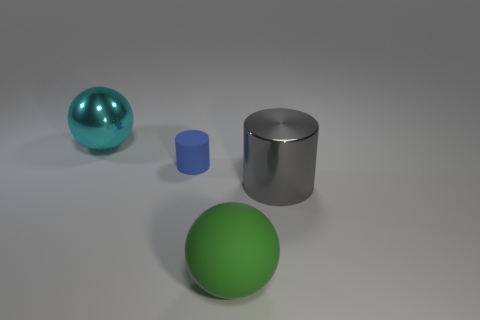Add 4 yellow matte cylinders. How many objects exist? 8 Add 3 large shiny cylinders. How many large shiny cylinders exist? 4 Subtract 0 blue blocks. How many objects are left? 4 Subtract all big metal cubes. Subtract all blue cylinders. How many objects are left? 3 Add 2 blue matte things. How many blue matte things are left? 3 